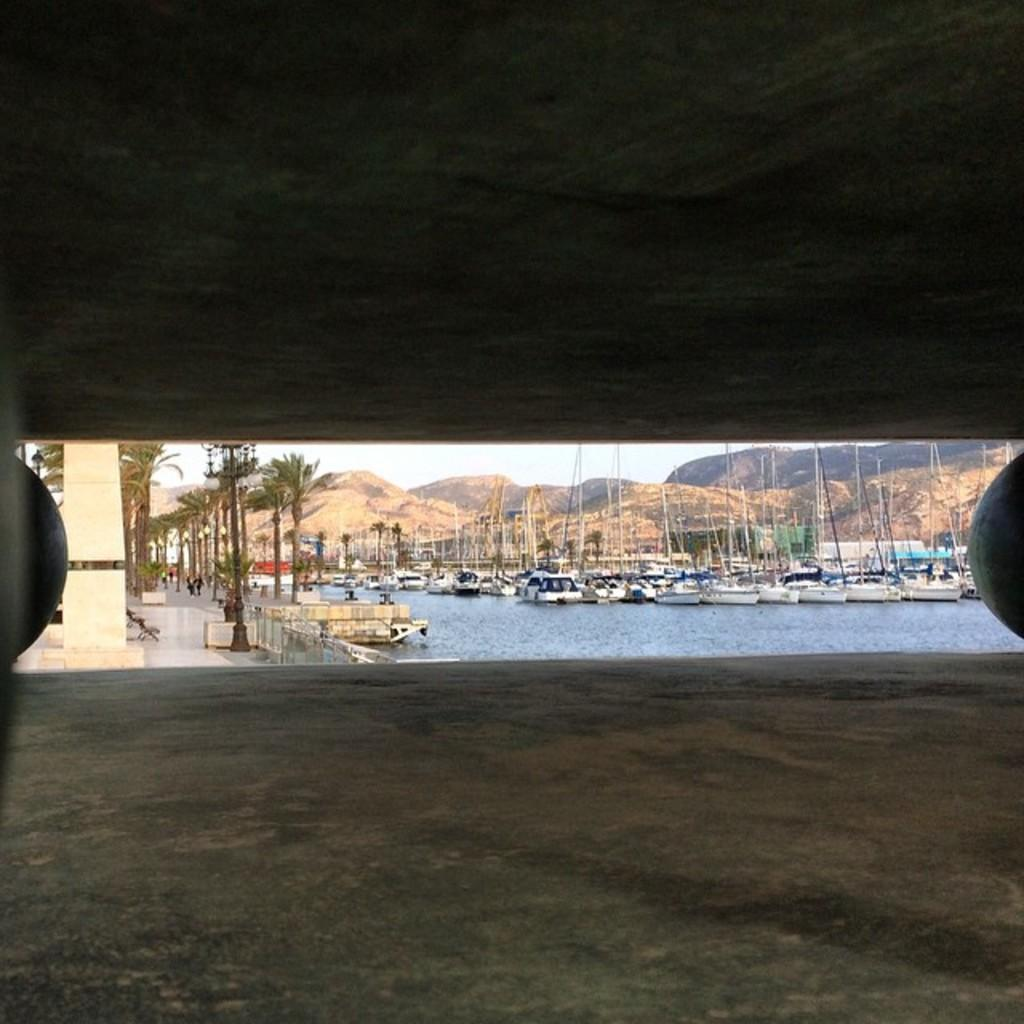What type of natural formations can be seen in the image? There are rocks and hills in the image. What is present on the water in the image? There are boats on the water in the image. What type of vegetation is visible in the image? There are trees in the image. What part of the natural environment is visible in the image? The sky is visible in the image. Reasoning: Let' Let's think step by step in order to produce the conversation. We start by identifying the main subjects and objects in the image based on the provided facts. We then formulate questions that focus on the location and characteristics of these subjects and objects, ensuring that each question can be answered definitively with the information given. We avoid yes/no questions and ensure that the language is simple and clear. Absurd Question/Answer: Where is the crown placed on the table in the image? There is no crown or table present in the image. What type of coach can be seen driving through the hills in the image? There is no coach present in the image; it features rocks, boats, trees, hills, and the sky. Where is the crown placed on the table in the image? There is no crown or table present in the image. What type of coach can be seen driving through the hills in the image? There is no coach present in the image; it features rocks, boats, trees, hills, and the sky. 